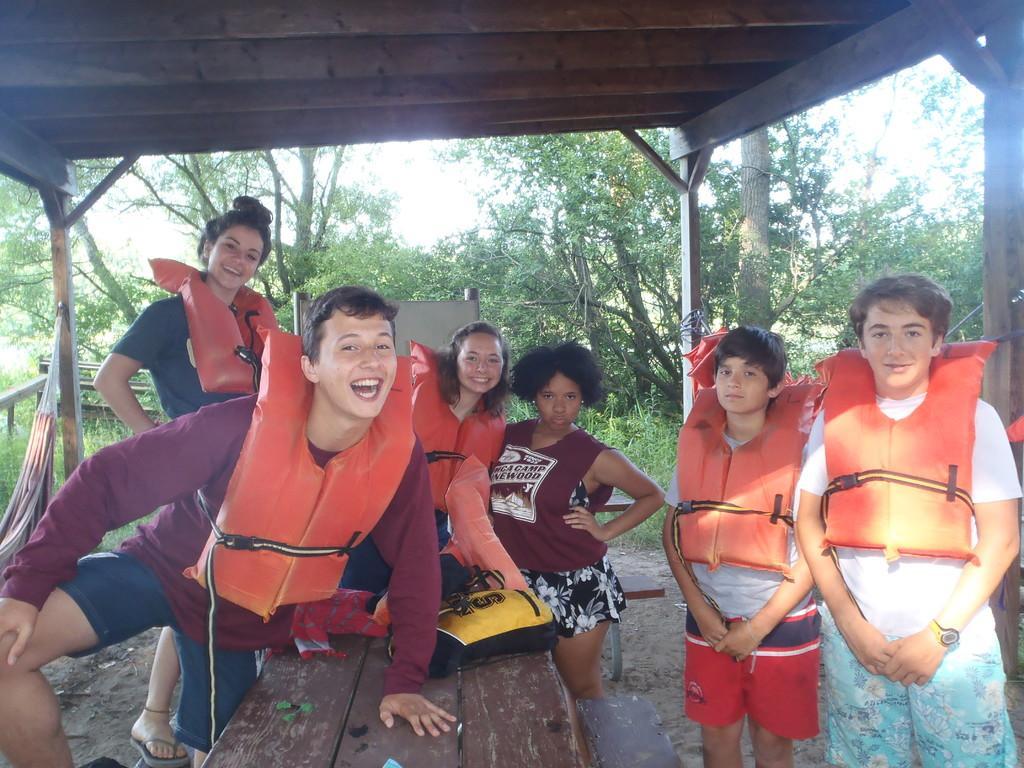Describe this image in one or two sentences. In this image we can see people some of them are wearing jackets. At the bottom there is a table and we can see a bag placed on the table. In the background there are trees. At the top there is a roof. On the left we can see a bench. 